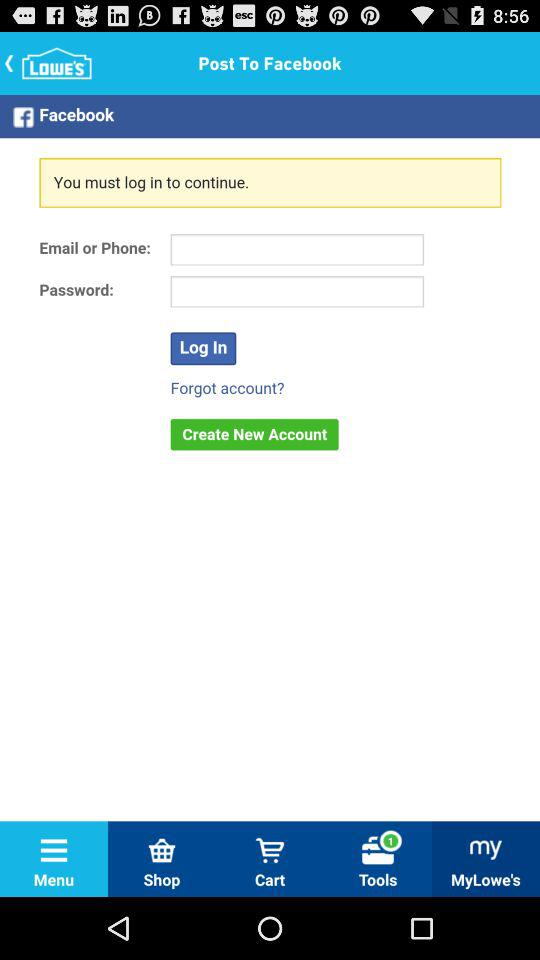Which tab has been selected? The tab that has been selected is "MyLowe's". 